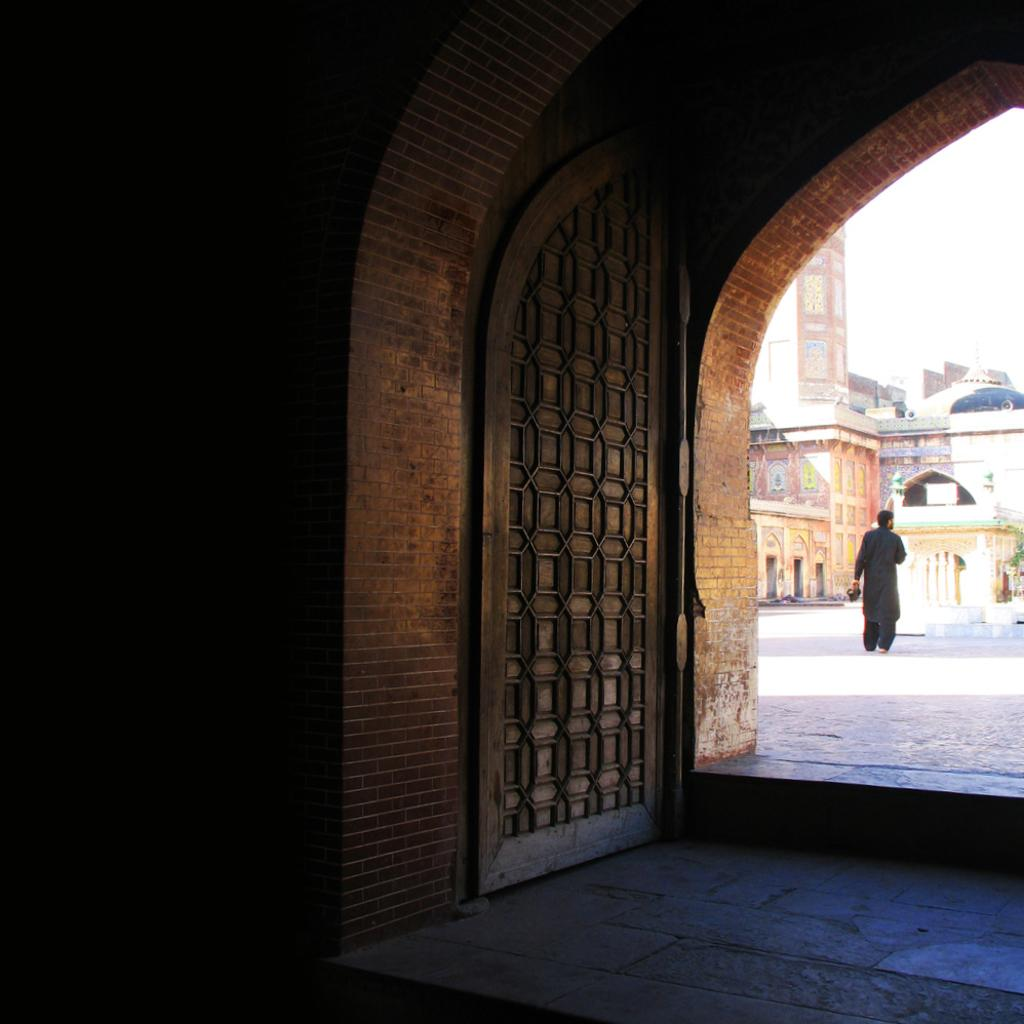What is located in the foreground of the picture? There is a gate and a brick wall in the foreground of the picture. What can be seen in the background of the picture? There are buildings, a road, and a person in the background of the picture. How is the weather in the image? The sky is sunny in the image. What type of cart is being used by the person in the image? There is no cart present in the image; only a person is visible in the background. Is there a shop visible in the image? There is no shop mentioned or visible in the image. 